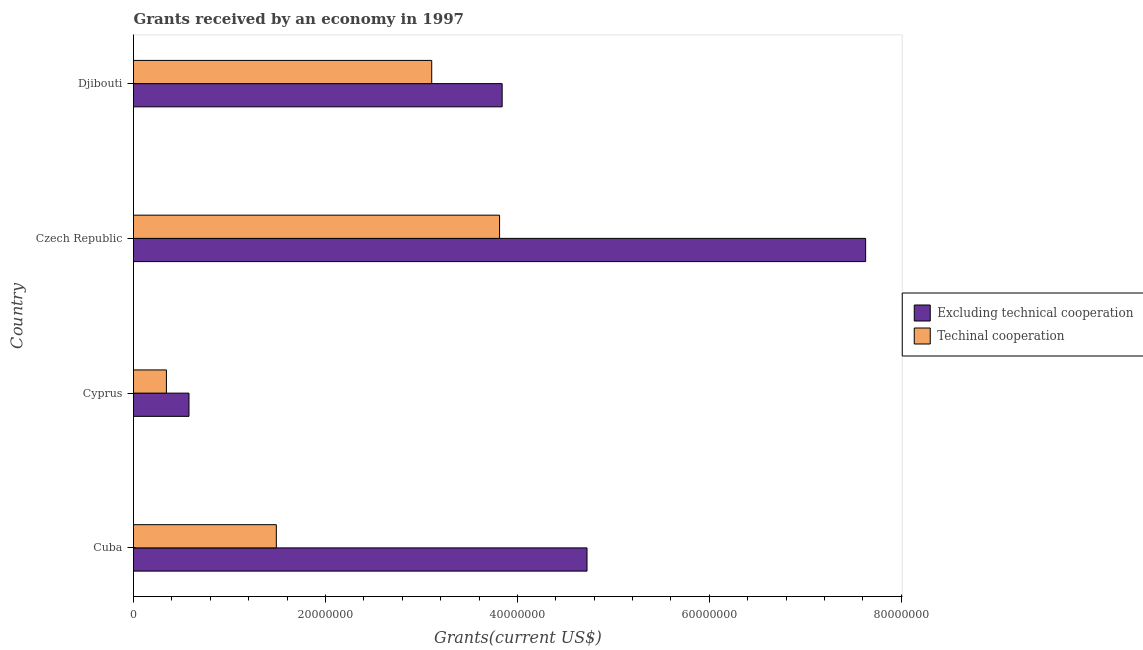How many groups of bars are there?
Offer a very short reply. 4. Are the number of bars on each tick of the Y-axis equal?
Give a very brief answer. Yes. How many bars are there on the 3rd tick from the bottom?
Your response must be concise. 2. What is the label of the 3rd group of bars from the top?
Offer a very short reply. Cyprus. What is the amount of grants received(including technical cooperation) in Cuba?
Give a very brief answer. 1.49e+07. Across all countries, what is the maximum amount of grants received(including technical cooperation)?
Provide a short and direct response. 3.81e+07. Across all countries, what is the minimum amount of grants received(including technical cooperation)?
Offer a very short reply. 3.43e+06. In which country was the amount of grants received(excluding technical cooperation) maximum?
Your answer should be very brief. Czech Republic. In which country was the amount of grants received(including technical cooperation) minimum?
Offer a terse response. Cyprus. What is the total amount of grants received(excluding technical cooperation) in the graph?
Make the answer very short. 1.68e+08. What is the difference between the amount of grants received(including technical cooperation) in Cuba and that in Djibouti?
Offer a very short reply. -1.62e+07. What is the difference between the amount of grants received(including technical cooperation) in Czech Republic and the amount of grants received(excluding technical cooperation) in Cuba?
Provide a short and direct response. -9.11e+06. What is the average amount of grants received(excluding technical cooperation) per country?
Give a very brief answer. 4.19e+07. What is the difference between the amount of grants received(excluding technical cooperation) and amount of grants received(including technical cooperation) in Czech Republic?
Offer a very short reply. 3.81e+07. What is the ratio of the amount of grants received(excluding technical cooperation) in Cuba to that in Cyprus?
Your answer should be very brief. 8.18. What is the difference between the highest and the second highest amount of grants received(excluding technical cooperation)?
Give a very brief answer. 2.90e+07. What is the difference between the highest and the lowest amount of grants received(excluding technical cooperation)?
Offer a terse response. 7.05e+07. Is the sum of the amount of grants received(excluding technical cooperation) in Czech Republic and Djibouti greater than the maximum amount of grants received(including technical cooperation) across all countries?
Offer a terse response. Yes. What does the 2nd bar from the top in Czech Republic represents?
Offer a terse response. Excluding technical cooperation. What does the 2nd bar from the bottom in Cuba represents?
Make the answer very short. Techinal cooperation. How many bars are there?
Your answer should be very brief. 8. How many countries are there in the graph?
Give a very brief answer. 4. What is the difference between two consecutive major ticks on the X-axis?
Your response must be concise. 2.00e+07. Does the graph contain any zero values?
Offer a terse response. No. How many legend labels are there?
Make the answer very short. 2. How are the legend labels stacked?
Ensure brevity in your answer.  Vertical. What is the title of the graph?
Offer a very short reply. Grants received by an economy in 1997. What is the label or title of the X-axis?
Provide a succinct answer. Grants(current US$). What is the label or title of the Y-axis?
Your response must be concise. Country. What is the Grants(current US$) in Excluding technical cooperation in Cuba?
Provide a succinct answer. 4.72e+07. What is the Grants(current US$) in Techinal cooperation in Cuba?
Give a very brief answer. 1.49e+07. What is the Grants(current US$) in Excluding technical cooperation in Cyprus?
Ensure brevity in your answer.  5.78e+06. What is the Grants(current US$) of Techinal cooperation in Cyprus?
Your response must be concise. 3.43e+06. What is the Grants(current US$) in Excluding technical cooperation in Czech Republic?
Make the answer very short. 7.63e+07. What is the Grants(current US$) of Techinal cooperation in Czech Republic?
Offer a terse response. 3.81e+07. What is the Grants(current US$) of Excluding technical cooperation in Djibouti?
Offer a terse response. 3.84e+07. What is the Grants(current US$) of Techinal cooperation in Djibouti?
Offer a terse response. 3.11e+07. Across all countries, what is the maximum Grants(current US$) in Excluding technical cooperation?
Your response must be concise. 7.63e+07. Across all countries, what is the maximum Grants(current US$) in Techinal cooperation?
Provide a succinct answer. 3.81e+07. Across all countries, what is the minimum Grants(current US$) in Excluding technical cooperation?
Your response must be concise. 5.78e+06. Across all countries, what is the minimum Grants(current US$) in Techinal cooperation?
Your response must be concise. 3.43e+06. What is the total Grants(current US$) in Excluding technical cooperation in the graph?
Your response must be concise. 1.68e+08. What is the total Grants(current US$) of Techinal cooperation in the graph?
Offer a very short reply. 8.75e+07. What is the difference between the Grants(current US$) in Excluding technical cooperation in Cuba and that in Cyprus?
Your response must be concise. 4.15e+07. What is the difference between the Grants(current US$) in Techinal cooperation in Cuba and that in Cyprus?
Provide a succinct answer. 1.14e+07. What is the difference between the Grants(current US$) of Excluding technical cooperation in Cuba and that in Czech Republic?
Make the answer very short. -2.90e+07. What is the difference between the Grants(current US$) of Techinal cooperation in Cuba and that in Czech Republic?
Keep it short and to the point. -2.33e+07. What is the difference between the Grants(current US$) in Excluding technical cooperation in Cuba and that in Djibouti?
Your answer should be very brief. 8.84e+06. What is the difference between the Grants(current US$) in Techinal cooperation in Cuba and that in Djibouti?
Offer a very short reply. -1.62e+07. What is the difference between the Grants(current US$) in Excluding technical cooperation in Cyprus and that in Czech Republic?
Your answer should be very brief. -7.05e+07. What is the difference between the Grants(current US$) of Techinal cooperation in Cyprus and that in Czech Republic?
Offer a very short reply. -3.47e+07. What is the difference between the Grants(current US$) in Excluding technical cooperation in Cyprus and that in Djibouti?
Provide a succinct answer. -3.26e+07. What is the difference between the Grants(current US$) of Techinal cooperation in Cyprus and that in Djibouti?
Give a very brief answer. -2.76e+07. What is the difference between the Grants(current US$) of Excluding technical cooperation in Czech Republic and that in Djibouti?
Provide a short and direct response. 3.79e+07. What is the difference between the Grants(current US$) in Techinal cooperation in Czech Republic and that in Djibouti?
Keep it short and to the point. 7.07e+06. What is the difference between the Grants(current US$) in Excluding technical cooperation in Cuba and the Grants(current US$) in Techinal cooperation in Cyprus?
Offer a terse response. 4.38e+07. What is the difference between the Grants(current US$) in Excluding technical cooperation in Cuba and the Grants(current US$) in Techinal cooperation in Czech Republic?
Your response must be concise. 9.11e+06. What is the difference between the Grants(current US$) in Excluding technical cooperation in Cuba and the Grants(current US$) in Techinal cooperation in Djibouti?
Keep it short and to the point. 1.62e+07. What is the difference between the Grants(current US$) in Excluding technical cooperation in Cyprus and the Grants(current US$) in Techinal cooperation in Czech Republic?
Your answer should be very brief. -3.24e+07. What is the difference between the Grants(current US$) of Excluding technical cooperation in Cyprus and the Grants(current US$) of Techinal cooperation in Djibouti?
Keep it short and to the point. -2.53e+07. What is the difference between the Grants(current US$) of Excluding technical cooperation in Czech Republic and the Grants(current US$) of Techinal cooperation in Djibouti?
Your answer should be compact. 4.52e+07. What is the average Grants(current US$) in Excluding technical cooperation per country?
Provide a short and direct response. 4.19e+07. What is the average Grants(current US$) in Techinal cooperation per country?
Offer a very short reply. 2.19e+07. What is the difference between the Grants(current US$) of Excluding technical cooperation and Grants(current US$) of Techinal cooperation in Cuba?
Ensure brevity in your answer.  3.24e+07. What is the difference between the Grants(current US$) of Excluding technical cooperation and Grants(current US$) of Techinal cooperation in Cyprus?
Offer a very short reply. 2.35e+06. What is the difference between the Grants(current US$) of Excluding technical cooperation and Grants(current US$) of Techinal cooperation in Czech Republic?
Provide a succinct answer. 3.81e+07. What is the difference between the Grants(current US$) in Excluding technical cooperation and Grants(current US$) in Techinal cooperation in Djibouti?
Your answer should be very brief. 7.34e+06. What is the ratio of the Grants(current US$) in Excluding technical cooperation in Cuba to that in Cyprus?
Provide a succinct answer. 8.17. What is the ratio of the Grants(current US$) of Techinal cooperation in Cuba to that in Cyprus?
Offer a terse response. 4.34. What is the ratio of the Grants(current US$) in Excluding technical cooperation in Cuba to that in Czech Republic?
Your response must be concise. 0.62. What is the ratio of the Grants(current US$) in Techinal cooperation in Cuba to that in Czech Republic?
Make the answer very short. 0.39. What is the ratio of the Grants(current US$) in Excluding technical cooperation in Cuba to that in Djibouti?
Provide a succinct answer. 1.23. What is the ratio of the Grants(current US$) of Techinal cooperation in Cuba to that in Djibouti?
Your answer should be compact. 0.48. What is the ratio of the Grants(current US$) in Excluding technical cooperation in Cyprus to that in Czech Republic?
Keep it short and to the point. 0.08. What is the ratio of the Grants(current US$) in Techinal cooperation in Cyprus to that in Czech Republic?
Provide a short and direct response. 0.09. What is the ratio of the Grants(current US$) of Excluding technical cooperation in Cyprus to that in Djibouti?
Ensure brevity in your answer.  0.15. What is the ratio of the Grants(current US$) of Techinal cooperation in Cyprus to that in Djibouti?
Offer a terse response. 0.11. What is the ratio of the Grants(current US$) in Excluding technical cooperation in Czech Republic to that in Djibouti?
Provide a succinct answer. 1.99. What is the ratio of the Grants(current US$) of Techinal cooperation in Czech Republic to that in Djibouti?
Keep it short and to the point. 1.23. What is the difference between the highest and the second highest Grants(current US$) in Excluding technical cooperation?
Make the answer very short. 2.90e+07. What is the difference between the highest and the second highest Grants(current US$) of Techinal cooperation?
Make the answer very short. 7.07e+06. What is the difference between the highest and the lowest Grants(current US$) in Excluding technical cooperation?
Give a very brief answer. 7.05e+07. What is the difference between the highest and the lowest Grants(current US$) in Techinal cooperation?
Offer a very short reply. 3.47e+07. 